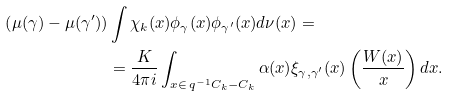Convert formula to latex. <formula><loc_0><loc_0><loc_500><loc_500>\left ( \mu ( \gamma ) - \mu ( \gamma ^ { \prime } ) \right ) & \int \chi _ { k } ( x ) \phi _ { \gamma } ( x ) \phi _ { \gamma ^ { \prime } } ( x ) d \nu ( x ) = \\ & = \frac { K } { 4 \pi i } \int _ { x \in \, q ^ { - 1 } C _ { k } - C _ { k } } \alpha ( x ) \xi _ { \gamma , \gamma ^ { \prime } } ( x ) \left ( \frac { W ( x ) } { x } \right ) d x .</formula> 